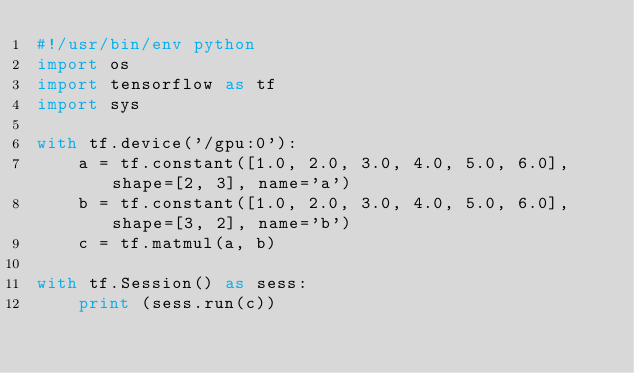<code> <loc_0><loc_0><loc_500><loc_500><_Python_>#!/usr/bin/env python
import os
import tensorflow as tf
import sys

with tf.device('/gpu:0'):
    a = tf.constant([1.0, 2.0, 3.0, 4.0, 5.0, 6.0], shape=[2, 3], name='a')
    b = tf.constant([1.0, 2.0, 3.0, 4.0, 5.0, 6.0], shape=[3, 2], name='b')
    c = tf.matmul(a, b)

with tf.Session() as sess:
    print (sess.run(c))
</code> 